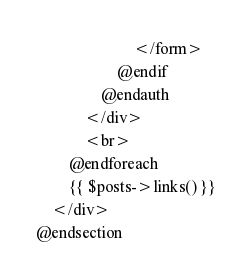<code> <loc_0><loc_0><loc_500><loc_500><_PHP_>                        </form>
                    @endif
                @endauth
            </div>
            <br>
        @endforeach
        {{ $posts->links() }}
    </div>
@endsection
</code> 